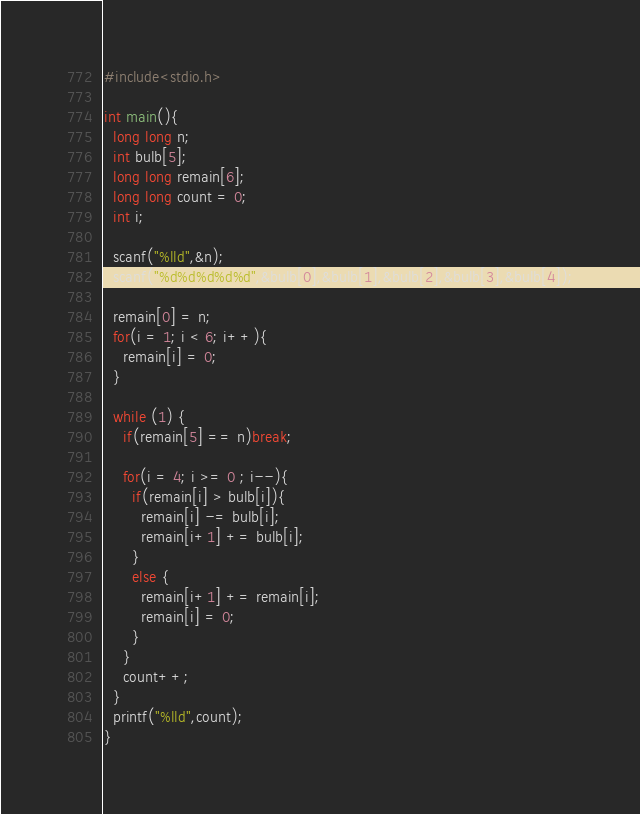<code> <loc_0><loc_0><loc_500><loc_500><_C_>#include<stdio.h>

int main(){
  long long n;
  int bulb[5];
  long long remain[6];
  long long count = 0;
  int i;

  scanf("%lld",&n);
  scanf("%d%d%d%d%d",&bulb[0],&bulb[1],&bulb[2],&bulb[3],&bulb[4]);

  remain[0] = n;
  for(i = 1; i < 6; i++){
    remain[i] = 0;
  }

  while (1) {
    if(remain[5] == n)break;

    for(i = 4; i >= 0 ; i--){
      if(remain[i] > bulb[i]){
        remain[i] -= bulb[i];
        remain[i+1] += bulb[i];
      }
      else {
        remain[i+1] += remain[i];
        remain[i] = 0;
      }
    }
    count++;
  }
  printf("%lld",count);
}
</code> 